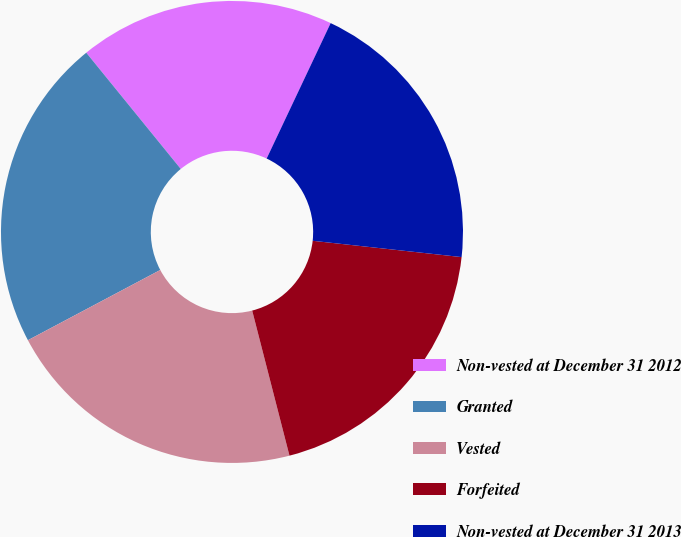Convert chart to OTSL. <chart><loc_0><loc_0><loc_500><loc_500><pie_chart><fcel>Non-vested at December 31 2012<fcel>Granted<fcel>Vested<fcel>Forfeited<fcel>Non-vested at December 31 2013<nl><fcel>17.89%<fcel>21.9%<fcel>21.24%<fcel>19.26%<fcel>19.71%<nl></chart> 